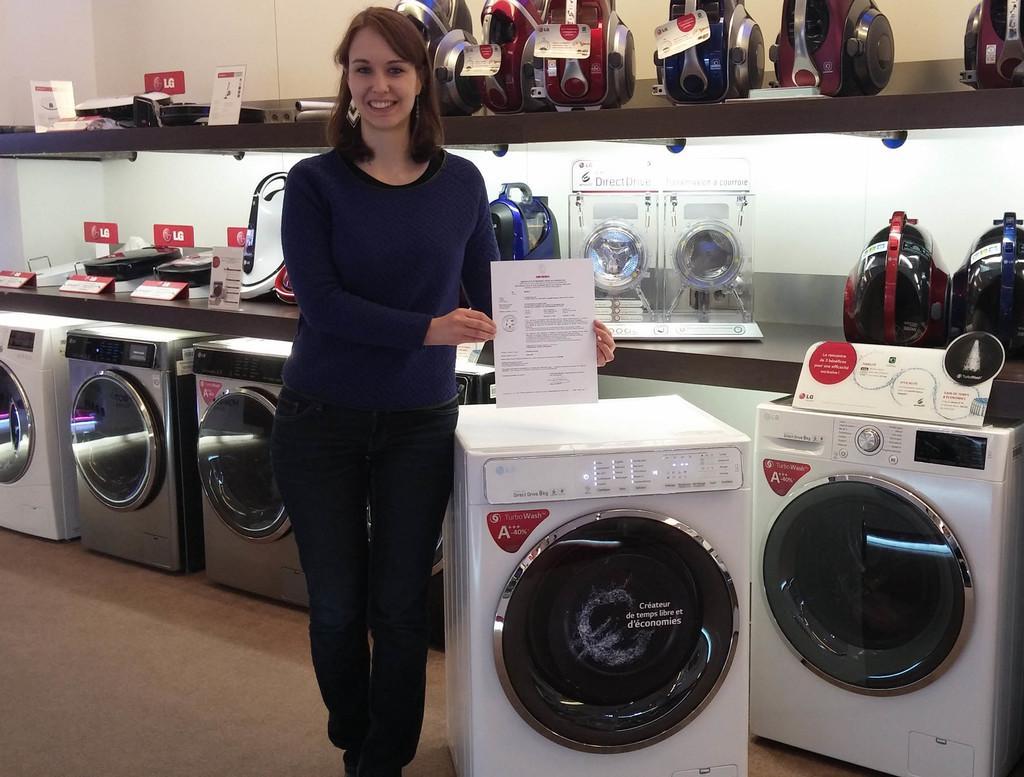Describe this image in one or two sentences. In this picture we can see the inside view of the shop. In the front we can see the woman, standing in the front, smiling and giving a pose to the camera. Beside we can see white washing machines. Behind there are some production in the rack. 